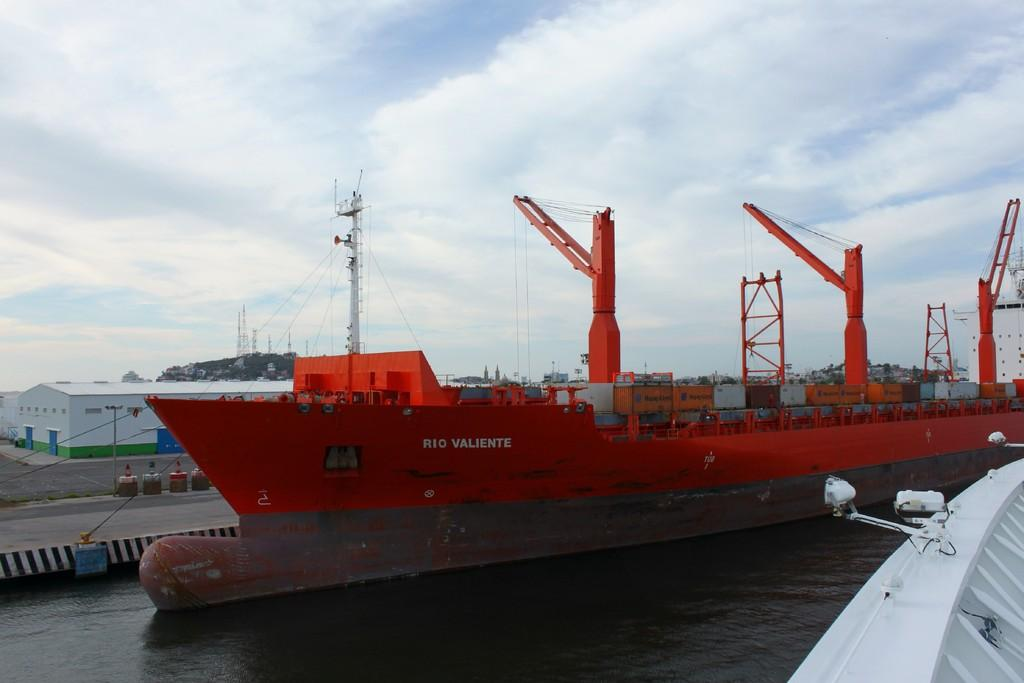<image>
Give a short and clear explanation of the subsequent image. A large ship called Rio Valiente is painted red. 